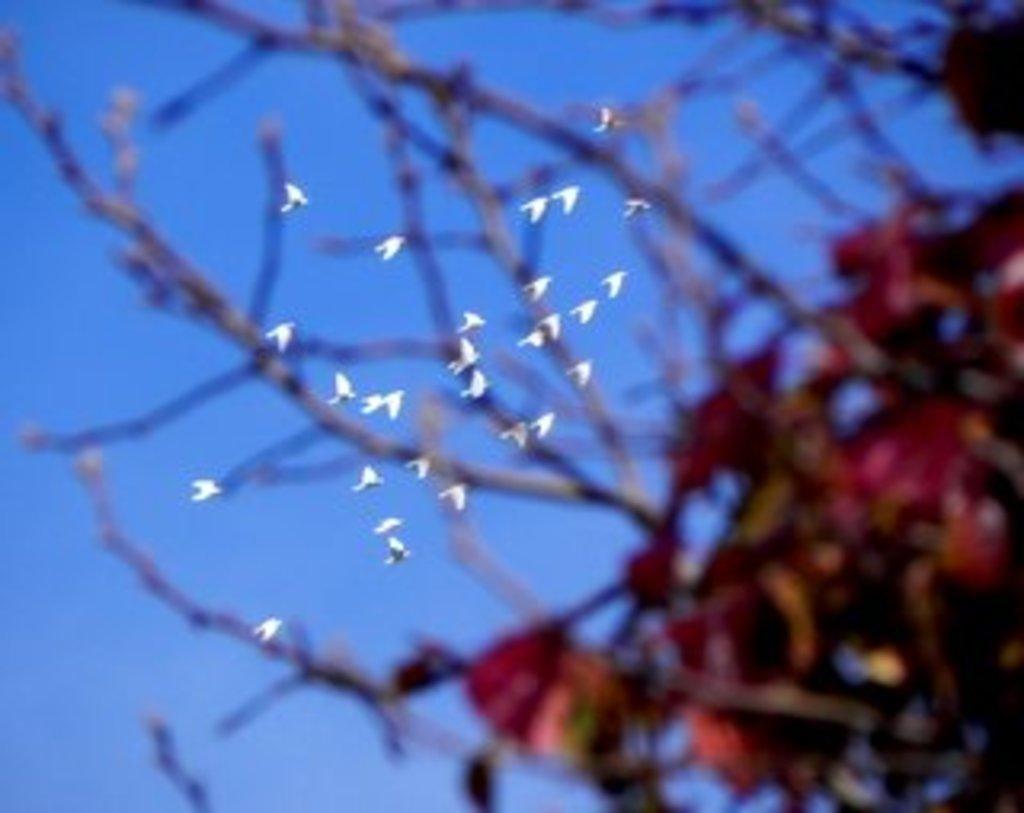How would you summarize this image in a sentence or two? In this image there are branches of a tree, at the top of the image there are few birds flying in the sky. 